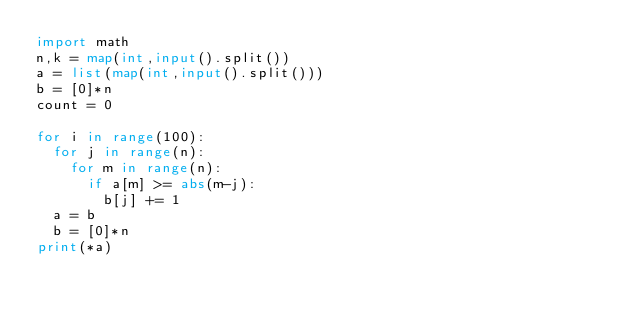<code> <loc_0><loc_0><loc_500><loc_500><_Python_>import math
n,k = map(int,input().split())
a = list(map(int,input().split()))
b = [0]*n
count = 0

for i in range(100):
  for j in range(n):
    for m in range(n):
      if a[m] >= abs(m-j):
        b[j] += 1
  a = b  
  b = [0]*n
print(*a)
</code> 